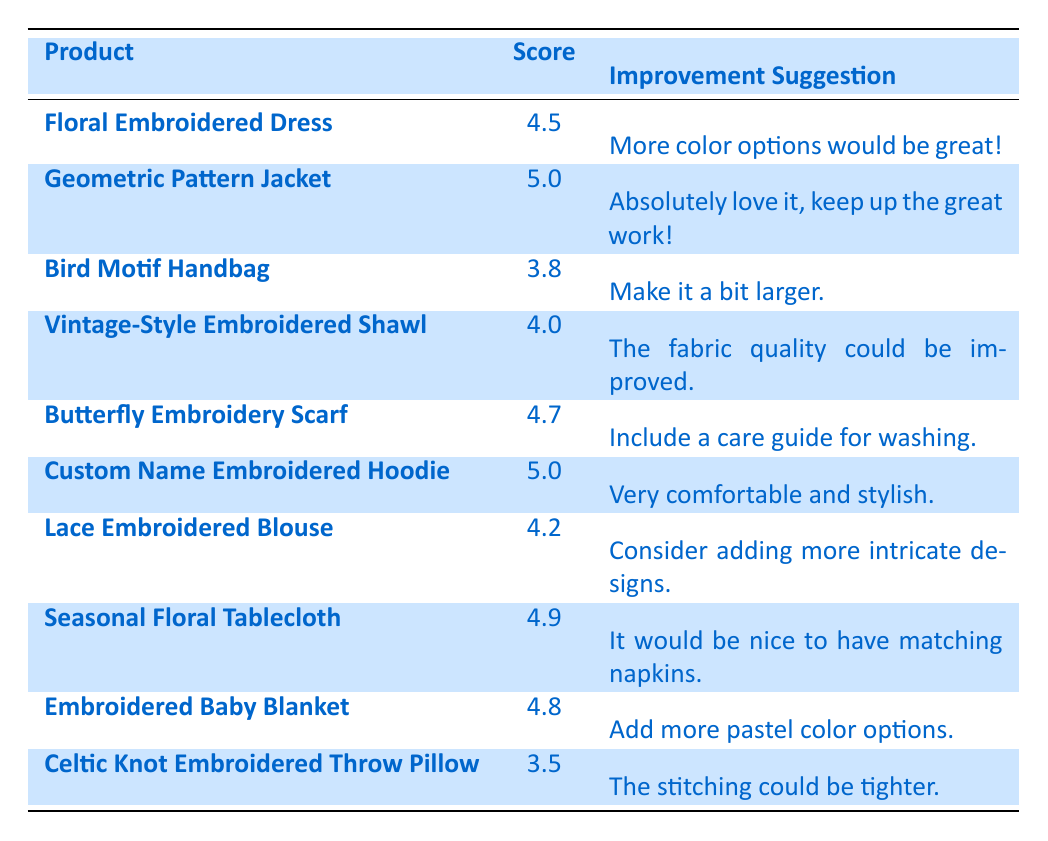What is the highest feedback score for a product? The highest score in the table is 5.0, which appears for both the "Geometric Pattern Jacket" and "Custom Name Embroidered Hoodie" products.
Answer: 5.0 Which product received the lowest score? The lowest score in the table is 3.5, given to the "Celtic Knot Embroidered Throw Pillow."
Answer: 3.5 What improvement suggestion was made for the "Bird Motif Handbag"? The suggestion mentioned for the "Bird Motif Handbag" is to "Make it a bit larger." This is stated directly in the table.
Answer: Make it a bit larger What is the average feedback score for all products listed? To calculate the average, sum the scores: (4.5 + 5.0 + 3.8 + 4.0 + 4.7 + 5.0 + 4.2 + 4.9 + 4.8 + 3.5) = 46.4. There are 10 products, so the average is 46.4 / 10 = 4.64.
Answer: 4.64 Did any product receive a feedback score of 4.0 or higher with the suggestion for more intricate designs? Yes, the "Lace Embroidered Blouse" received a score of 4.2 and the suggestion for adding more intricate designs.
Answer: Yes How many products received a score of 4.5 or above? There are 7 products that received a score of 4.5 or above. These are: "Floral Embroidered Dress," "Geometric Pattern Jacket," "Butterfly Embroidery Scarf," "Custom Name Embroidered Hoodie," "Lace Embroidered Blouse," "Seasonal Floral Tablecloth," and "Embroidered Baby Blanket."
Answer: 7 What suggestion is made for the product with the second-highest feedback score? The second-highest score is 4.9 for the "Seasonal Floral Tablecloth," and the suggestion is "It would be nice to have matching napkins."
Answer: It would be nice to have matching napkins Which products requested additional color options in their suggestions? The "Floral Embroidered Dress" suggested "More color options would be great!" and the "Embroidered Baby Blanket" suggested "Add more pastel color options." Thus, two products requested additional color options.
Answer: 2 What improvement did customers suggest for products with a score less than 4.0? The "Celtic Knot Embroidered Throw Pillow" has a score of 3.5, and the suggestion is "The stitching could be tighter." The "Bird Motif Handbag" with a score of 3.8 was suggested to "Make it a bit larger." Thus, there are two products with suggestions for improvement.
Answer: 2 